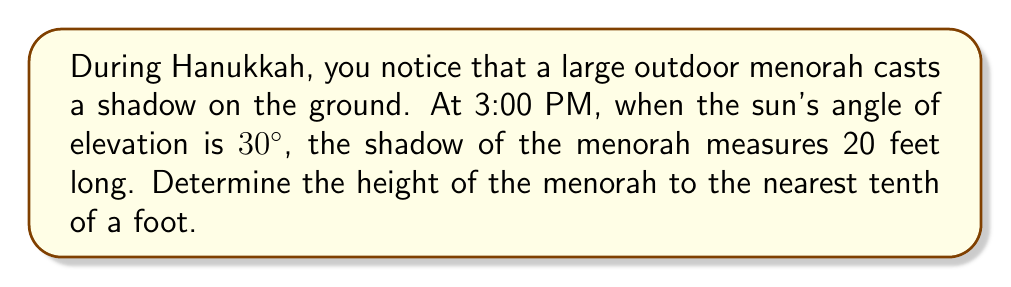Show me your answer to this math problem. To solve this problem, we'll use trigonometry, specifically the tangent function. Let's break it down step-by-step:

1) First, let's visualize the problem:

[asy]
import geometry;

size(200);

pair A = (0,0), B = (20,0), C = (0,11.55);
draw(A--B--C--A);

label("20 ft", (10,0), S);
label("h", (0,5.775), W);
label("30°", (1,0), NE);

draw(arc(A,1,0,30), Arrow);
[/asy]

2) In this right triangle:
   - The shadow length (20 feet) is the adjacent side to the 30° angle.
   - The height of the menorah (h) is the opposite side.
   - We need to find the opposite side using the tangent function.

3) The tangent of an angle in a right triangle is the ratio of the opposite side to the adjacent side:

   $$\tan(\theta) = \frac{\text{opposite}}{\text{adjacent}}$$

4) In this case:

   $$\tan(30°) = \frac{h}{20}$$

5) We know that $\tan(30°) = \frac{1}{\sqrt{3}} \approx 0.577$. Let's use this value:

   $$0.577 = \frac{h}{20}$$

6) To solve for h, multiply both sides by 20:

   $$h = 20 \times 0.577 = 11.54$$

7) Rounding to the nearest tenth:

   $$h \approx 11.5 \text{ feet}$$
Answer: The height of the menorah is approximately 11.5 feet. 